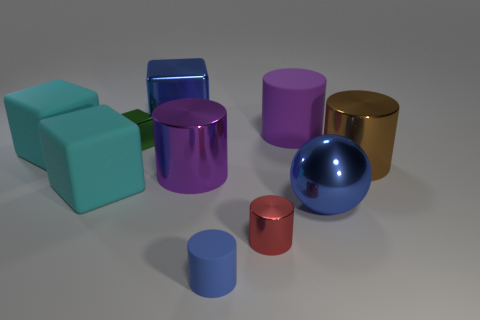Subtract all large rubber cylinders. How many cylinders are left? 4 Subtract 2 cylinders. How many cylinders are left? 3 Subtract all brown cylinders. How many cylinders are left? 4 Subtract all yellow cylinders. Subtract all yellow spheres. How many cylinders are left? 5 Subtract all cubes. How many objects are left? 6 Add 4 tiny cylinders. How many tiny cylinders exist? 6 Subtract 0 purple spheres. How many objects are left? 10 Subtract all big purple metal cylinders. Subtract all large purple blocks. How many objects are left? 9 Add 4 cyan objects. How many cyan objects are left? 6 